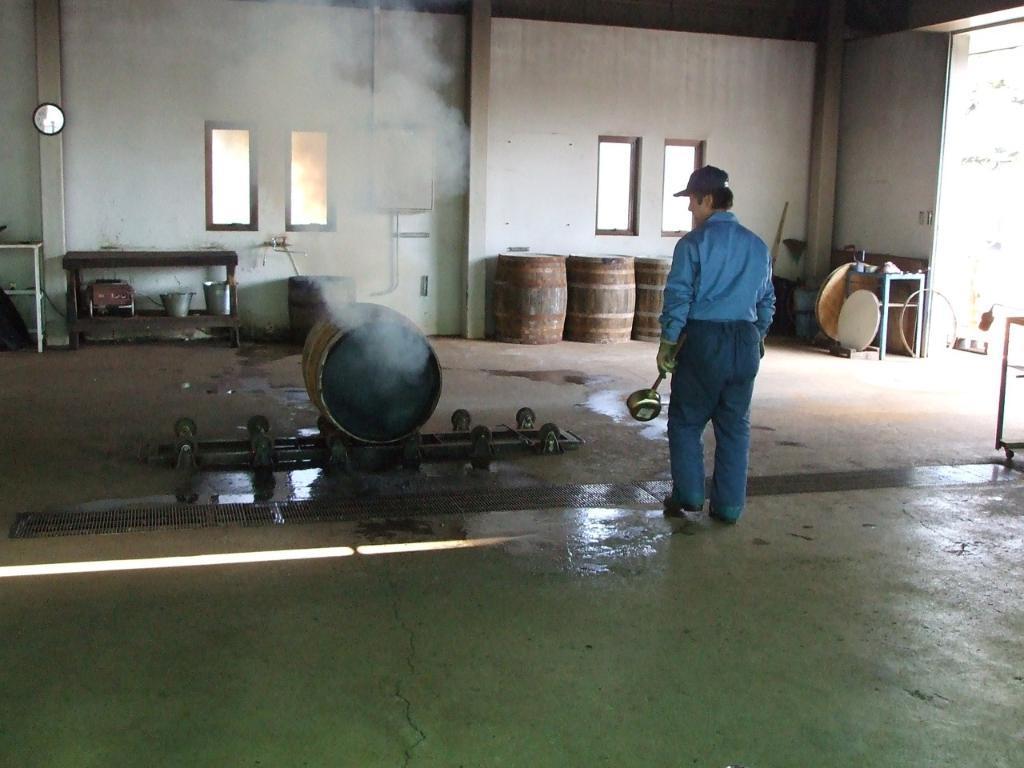Could you give a brief overview of what you see in this image? In the front of the image I can see a person is holding an object, barrel and things. Smoke is coming out from the barrel. In the background of the image there are barrels, windows, clock, tables and objects. 